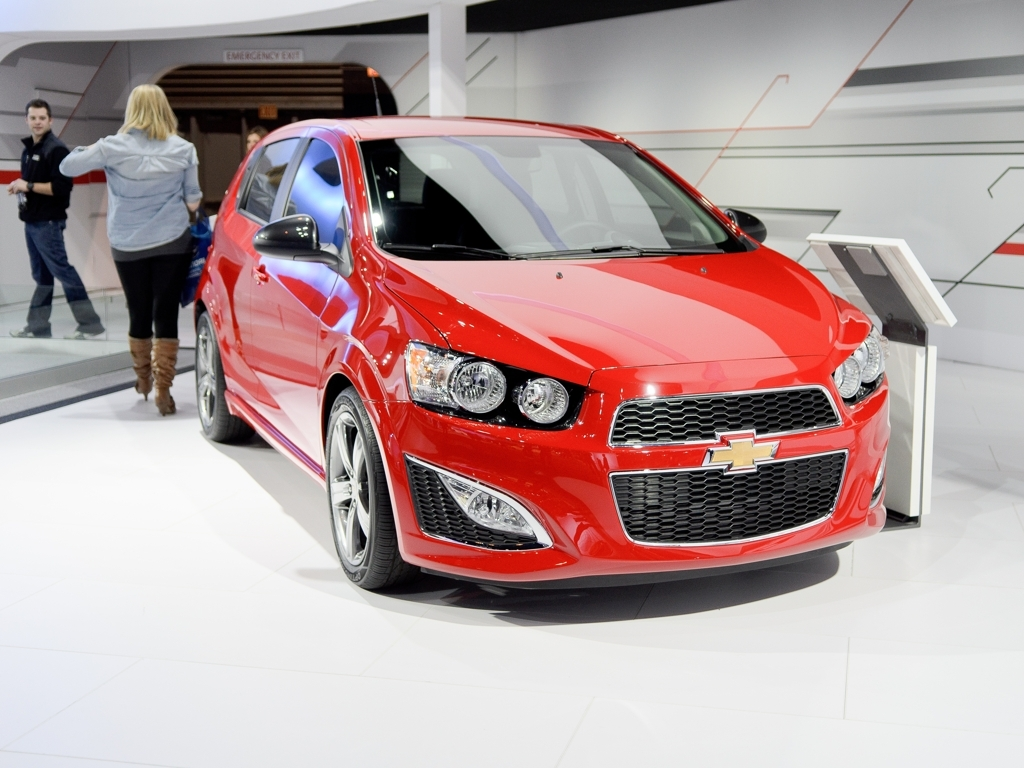What context or event do you think this image represents? Given the pristine condition of the car, the polished flooring, and the partition in the background, this appears to be an image from an auto show or exhibition. Such events are places where manufacturers display their latest models and features to the public and press, and the environment often emphasizes the visual appeal of the vehicles with carefully arranged lighting and decor. 